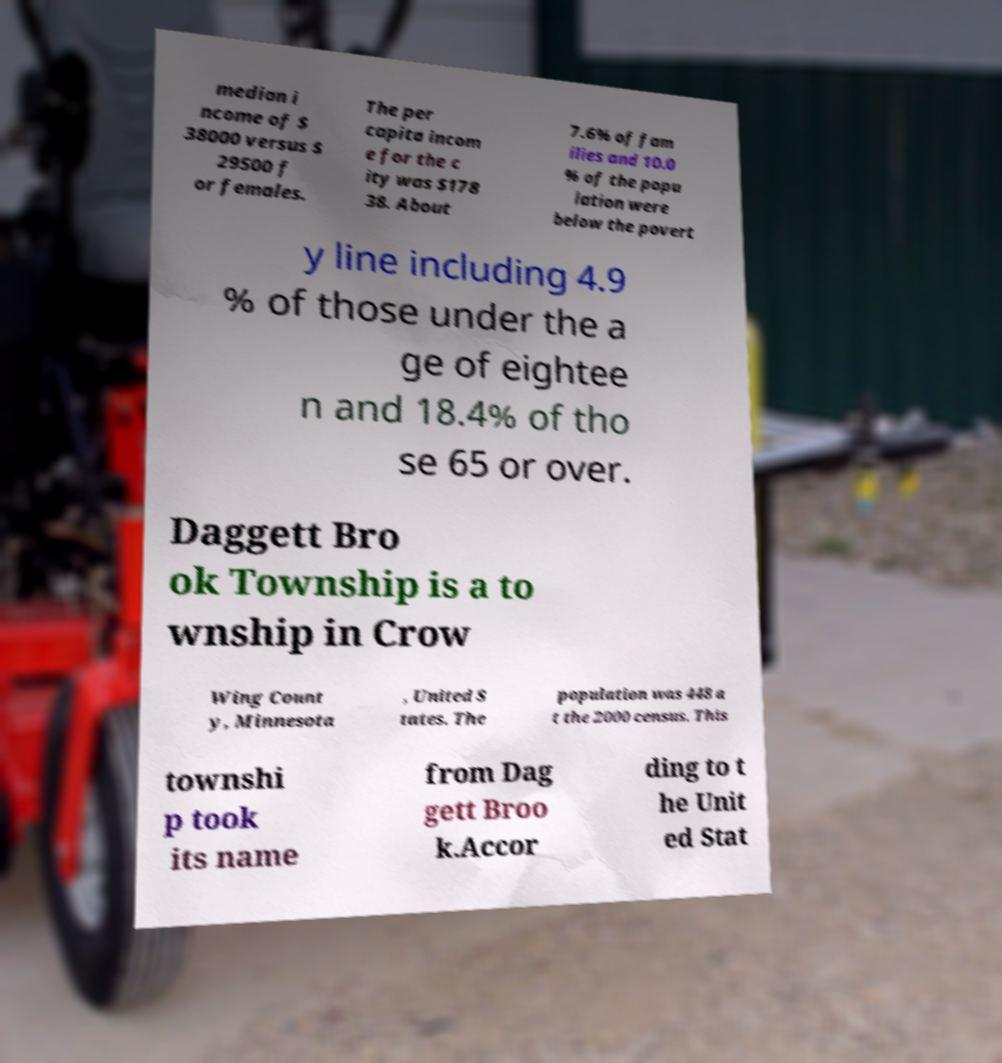There's text embedded in this image that I need extracted. Can you transcribe it verbatim? median i ncome of $ 38000 versus $ 29500 f or females. The per capita incom e for the c ity was $178 38. About 7.6% of fam ilies and 10.0 % of the popu lation were below the povert y line including 4.9 % of those under the a ge of eightee n and 18.4% of tho se 65 or over. Daggett Bro ok Township is a to wnship in Crow Wing Count y, Minnesota , United S tates. The population was 448 a t the 2000 census. This townshi p took its name from Dag gett Broo k.Accor ding to t he Unit ed Stat 